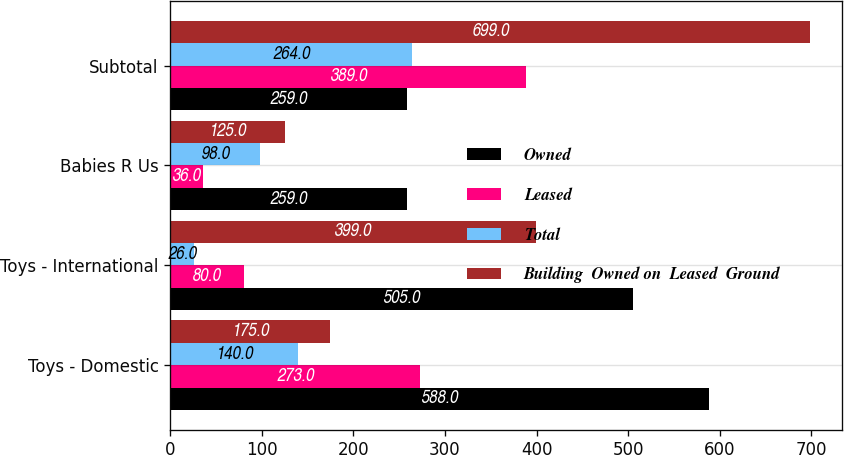Convert chart. <chart><loc_0><loc_0><loc_500><loc_500><stacked_bar_chart><ecel><fcel>Toys - Domestic<fcel>Toys - International<fcel>Babies R Us<fcel>Subtotal<nl><fcel>Owned<fcel>588<fcel>505<fcel>259<fcel>259<nl><fcel>Leased<fcel>273<fcel>80<fcel>36<fcel>389<nl><fcel>Total<fcel>140<fcel>26<fcel>98<fcel>264<nl><fcel>Building  Owned on  Leased  Ground<fcel>175<fcel>399<fcel>125<fcel>699<nl></chart> 